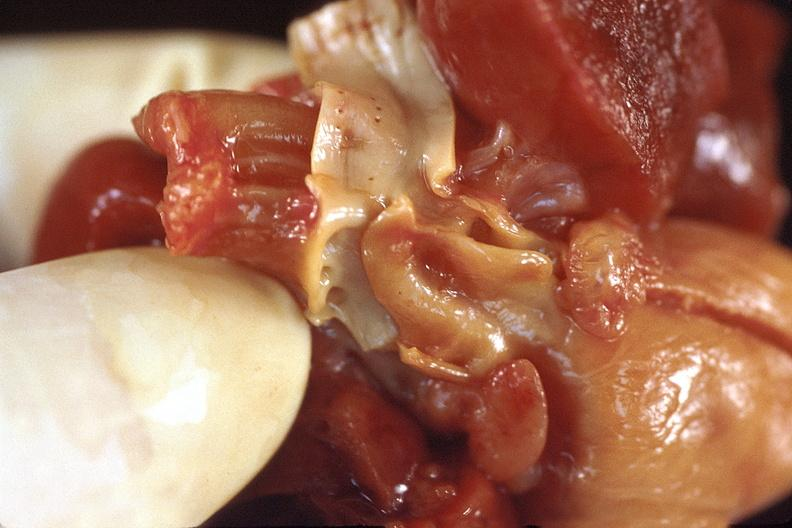s cardiovascular present?
Answer the question using a single word or phrase. Yes 